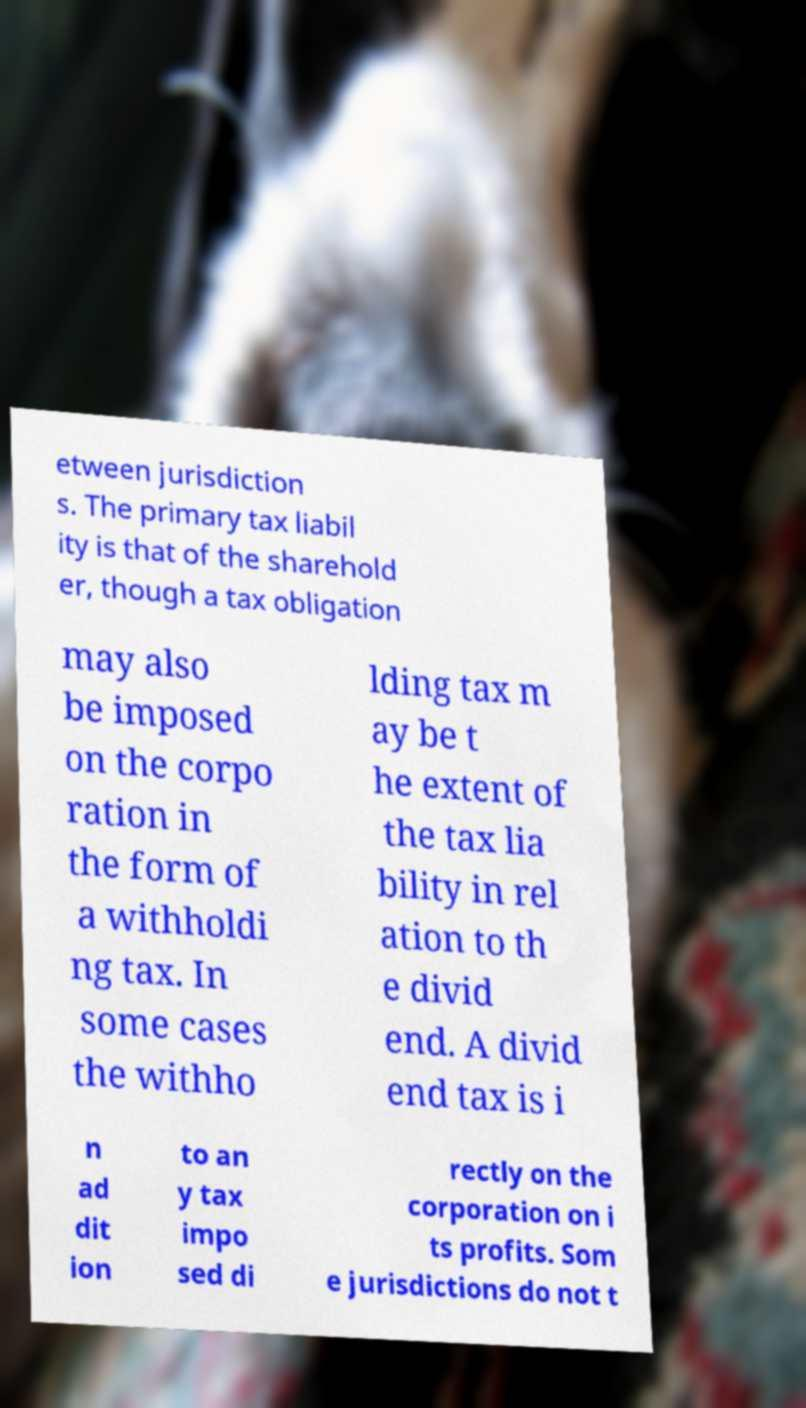Could you assist in decoding the text presented in this image and type it out clearly? etween jurisdiction s. The primary tax liabil ity is that of the sharehold er, though a tax obligation may also be imposed on the corpo ration in the form of a withholdi ng tax. In some cases the withho lding tax m ay be t he extent of the tax lia bility in rel ation to th e divid end. A divid end tax is i n ad dit ion to an y tax impo sed di rectly on the corporation on i ts profits. Som e jurisdictions do not t 